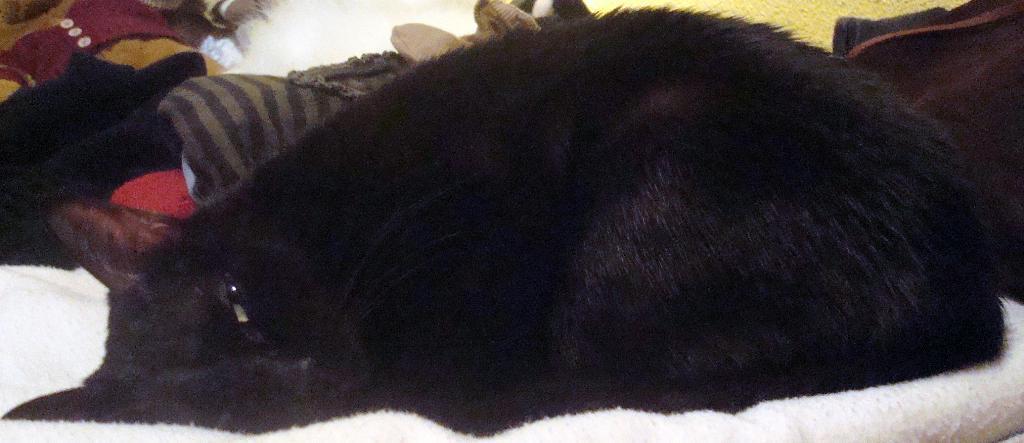Could you give a brief overview of what you see in this image? In the center of the image we can see a cat which is in black color lying on the white cloth. In the background there are clothes. 